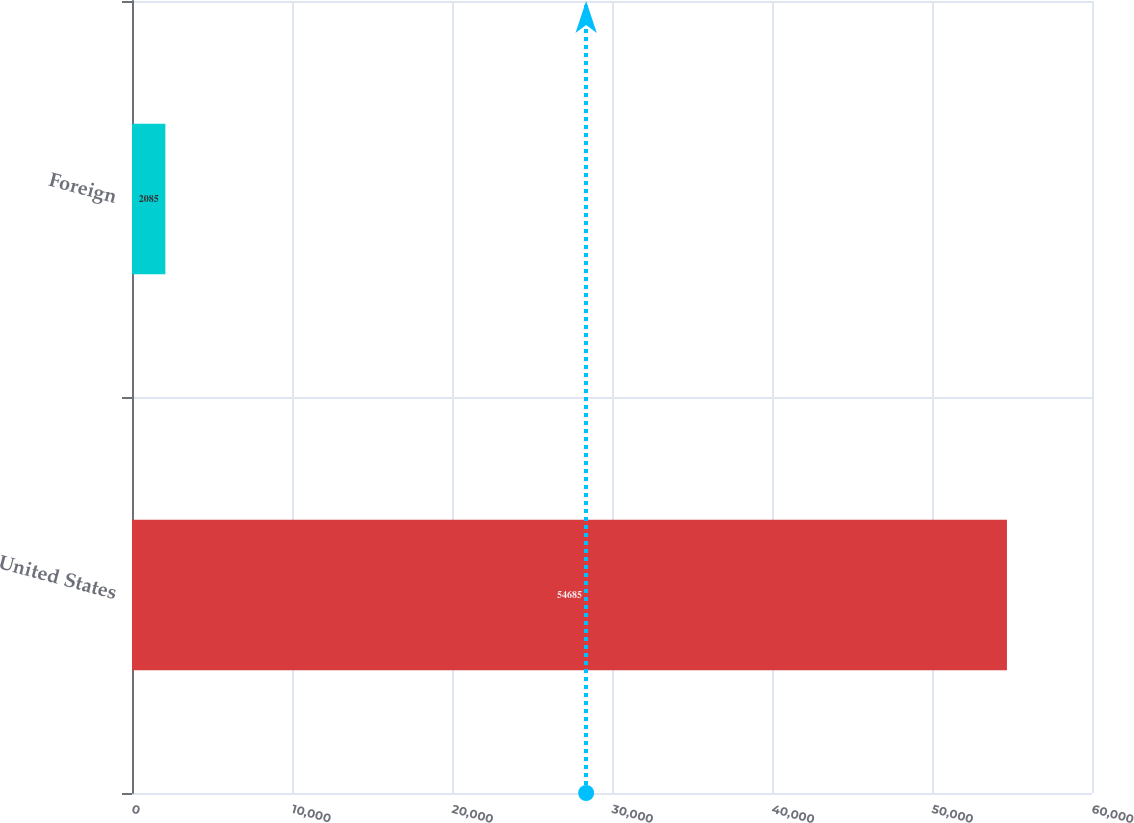<chart> <loc_0><loc_0><loc_500><loc_500><bar_chart><fcel>United States<fcel>Foreign<nl><fcel>54685<fcel>2085<nl></chart> 